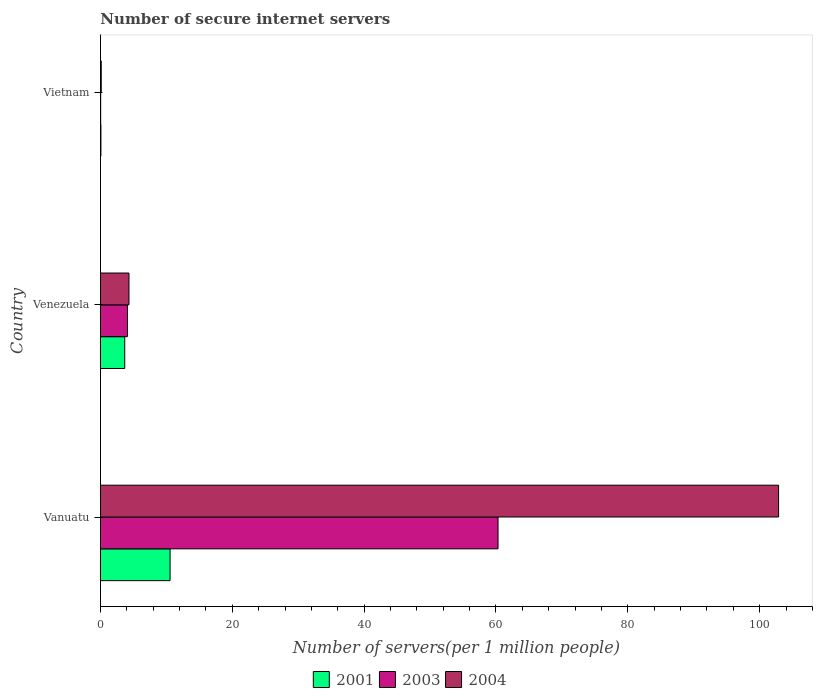How many different coloured bars are there?
Your response must be concise. 3. Are the number of bars per tick equal to the number of legend labels?
Your response must be concise. Yes. What is the label of the 3rd group of bars from the top?
Your answer should be compact. Vanuatu. What is the number of secure internet servers in 2001 in Venezuela?
Keep it short and to the point. 3.69. Across all countries, what is the maximum number of secure internet servers in 2001?
Your answer should be compact. 10.57. Across all countries, what is the minimum number of secure internet servers in 2001?
Ensure brevity in your answer.  0.08. In which country was the number of secure internet servers in 2004 maximum?
Your answer should be very brief. Vanuatu. In which country was the number of secure internet servers in 2001 minimum?
Provide a short and direct response. Vietnam. What is the total number of secure internet servers in 2001 in the graph?
Make the answer very short. 14.33. What is the difference between the number of secure internet servers in 2003 in Venezuela and that in Vietnam?
Offer a very short reply. 4.06. What is the difference between the number of secure internet servers in 2003 in Vietnam and the number of secure internet servers in 2004 in Vanuatu?
Provide a short and direct response. -102.83. What is the average number of secure internet servers in 2001 per country?
Provide a succinct answer. 4.78. What is the difference between the number of secure internet servers in 2004 and number of secure internet servers in 2001 in Venezuela?
Your answer should be compact. 0.64. What is the ratio of the number of secure internet servers in 2003 in Vanuatu to that in Venezuela?
Keep it short and to the point. 14.71. What is the difference between the highest and the second highest number of secure internet servers in 2003?
Give a very brief answer. 56.21. What is the difference between the highest and the lowest number of secure internet servers in 2004?
Your answer should be very brief. 102.75. In how many countries, is the number of secure internet servers in 2004 greater than the average number of secure internet servers in 2004 taken over all countries?
Offer a very short reply. 1. How many bars are there?
Your answer should be very brief. 9. How many countries are there in the graph?
Keep it short and to the point. 3. What is the difference between two consecutive major ticks on the X-axis?
Provide a succinct answer. 20. Where does the legend appear in the graph?
Keep it short and to the point. Bottom center. What is the title of the graph?
Keep it short and to the point. Number of secure internet servers. What is the label or title of the X-axis?
Provide a succinct answer. Number of servers(per 1 million people). What is the label or title of the Y-axis?
Offer a terse response. Country. What is the Number of servers(per 1 million people) of 2001 in Vanuatu?
Provide a succinct answer. 10.57. What is the Number of servers(per 1 million people) of 2003 in Vanuatu?
Give a very brief answer. 60.31. What is the Number of servers(per 1 million people) in 2004 in Vanuatu?
Make the answer very short. 102.87. What is the Number of servers(per 1 million people) of 2001 in Venezuela?
Ensure brevity in your answer.  3.69. What is the Number of servers(per 1 million people) of 2003 in Venezuela?
Keep it short and to the point. 4.1. What is the Number of servers(per 1 million people) in 2004 in Venezuela?
Your answer should be compact. 4.33. What is the Number of servers(per 1 million people) of 2001 in Vietnam?
Keep it short and to the point. 0.08. What is the Number of servers(per 1 million people) in 2003 in Vietnam?
Ensure brevity in your answer.  0.04. What is the Number of servers(per 1 million people) in 2004 in Vietnam?
Make the answer very short. 0.12. Across all countries, what is the maximum Number of servers(per 1 million people) in 2001?
Your response must be concise. 10.57. Across all countries, what is the maximum Number of servers(per 1 million people) of 2003?
Your answer should be very brief. 60.31. Across all countries, what is the maximum Number of servers(per 1 million people) in 2004?
Your response must be concise. 102.87. Across all countries, what is the minimum Number of servers(per 1 million people) of 2001?
Your answer should be compact. 0.08. Across all countries, what is the minimum Number of servers(per 1 million people) of 2003?
Make the answer very short. 0.04. Across all countries, what is the minimum Number of servers(per 1 million people) in 2004?
Provide a short and direct response. 0.12. What is the total Number of servers(per 1 million people) of 2001 in the graph?
Make the answer very short. 14.33. What is the total Number of servers(per 1 million people) of 2003 in the graph?
Keep it short and to the point. 64.45. What is the total Number of servers(per 1 million people) of 2004 in the graph?
Offer a terse response. 107.32. What is the difference between the Number of servers(per 1 million people) in 2001 in Vanuatu and that in Venezuela?
Offer a terse response. 6.88. What is the difference between the Number of servers(per 1 million people) in 2003 in Vanuatu and that in Venezuela?
Keep it short and to the point. 56.21. What is the difference between the Number of servers(per 1 million people) of 2004 in Vanuatu and that in Venezuela?
Keep it short and to the point. 98.54. What is the difference between the Number of servers(per 1 million people) of 2001 in Vanuatu and that in Vietnam?
Provide a succinct answer. 10.49. What is the difference between the Number of servers(per 1 million people) of 2003 in Vanuatu and that in Vietnam?
Keep it short and to the point. 60.28. What is the difference between the Number of servers(per 1 million people) of 2004 in Vanuatu and that in Vietnam?
Give a very brief answer. 102.75. What is the difference between the Number of servers(per 1 million people) of 2001 in Venezuela and that in Vietnam?
Provide a short and direct response. 3.61. What is the difference between the Number of servers(per 1 million people) in 2003 in Venezuela and that in Vietnam?
Give a very brief answer. 4.06. What is the difference between the Number of servers(per 1 million people) of 2004 in Venezuela and that in Vietnam?
Ensure brevity in your answer.  4.21. What is the difference between the Number of servers(per 1 million people) of 2001 in Vanuatu and the Number of servers(per 1 million people) of 2003 in Venezuela?
Provide a short and direct response. 6.47. What is the difference between the Number of servers(per 1 million people) in 2001 in Vanuatu and the Number of servers(per 1 million people) in 2004 in Venezuela?
Ensure brevity in your answer.  6.23. What is the difference between the Number of servers(per 1 million people) of 2003 in Vanuatu and the Number of servers(per 1 million people) of 2004 in Venezuela?
Offer a terse response. 55.98. What is the difference between the Number of servers(per 1 million people) of 2001 in Vanuatu and the Number of servers(per 1 million people) of 2003 in Vietnam?
Offer a very short reply. 10.53. What is the difference between the Number of servers(per 1 million people) of 2001 in Vanuatu and the Number of servers(per 1 million people) of 2004 in Vietnam?
Make the answer very short. 10.44. What is the difference between the Number of servers(per 1 million people) of 2003 in Vanuatu and the Number of servers(per 1 million people) of 2004 in Vietnam?
Give a very brief answer. 60.19. What is the difference between the Number of servers(per 1 million people) in 2001 in Venezuela and the Number of servers(per 1 million people) in 2003 in Vietnam?
Offer a terse response. 3.65. What is the difference between the Number of servers(per 1 million people) in 2001 in Venezuela and the Number of servers(per 1 million people) in 2004 in Vietnam?
Your answer should be very brief. 3.57. What is the difference between the Number of servers(per 1 million people) of 2003 in Venezuela and the Number of servers(per 1 million people) of 2004 in Vietnam?
Ensure brevity in your answer.  3.98. What is the average Number of servers(per 1 million people) of 2001 per country?
Your response must be concise. 4.78. What is the average Number of servers(per 1 million people) in 2003 per country?
Your response must be concise. 21.48. What is the average Number of servers(per 1 million people) of 2004 per country?
Give a very brief answer. 35.77. What is the difference between the Number of servers(per 1 million people) in 2001 and Number of servers(per 1 million people) in 2003 in Vanuatu?
Your answer should be compact. -49.75. What is the difference between the Number of servers(per 1 million people) in 2001 and Number of servers(per 1 million people) in 2004 in Vanuatu?
Offer a terse response. -92.3. What is the difference between the Number of servers(per 1 million people) of 2003 and Number of servers(per 1 million people) of 2004 in Vanuatu?
Ensure brevity in your answer.  -42.56. What is the difference between the Number of servers(per 1 million people) of 2001 and Number of servers(per 1 million people) of 2003 in Venezuela?
Offer a terse response. -0.41. What is the difference between the Number of servers(per 1 million people) in 2001 and Number of servers(per 1 million people) in 2004 in Venezuela?
Offer a terse response. -0.64. What is the difference between the Number of servers(per 1 million people) in 2003 and Number of servers(per 1 million people) in 2004 in Venezuela?
Ensure brevity in your answer.  -0.23. What is the difference between the Number of servers(per 1 million people) in 2001 and Number of servers(per 1 million people) in 2003 in Vietnam?
Offer a terse response. 0.04. What is the difference between the Number of servers(per 1 million people) of 2001 and Number of servers(per 1 million people) of 2004 in Vietnam?
Make the answer very short. -0.05. What is the difference between the Number of servers(per 1 million people) in 2003 and Number of servers(per 1 million people) in 2004 in Vietnam?
Keep it short and to the point. -0.09. What is the ratio of the Number of servers(per 1 million people) of 2001 in Vanuatu to that in Venezuela?
Offer a very short reply. 2.86. What is the ratio of the Number of servers(per 1 million people) in 2003 in Vanuatu to that in Venezuela?
Ensure brevity in your answer.  14.71. What is the ratio of the Number of servers(per 1 million people) in 2004 in Vanuatu to that in Venezuela?
Keep it short and to the point. 23.75. What is the ratio of the Number of servers(per 1 million people) of 2001 in Vanuatu to that in Vietnam?
Keep it short and to the point. 138.45. What is the ratio of the Number of servers(per 1 million people) of 2003 in Vanuatu to that in Vietnam?
Ensure brevity in your answer.  1617.74. What is the ratio of the Number of servers(per 1 million people) of 2004 in Vanuatu to that in Vietnam?
Ensure brevity in your answer.  837.72. What is the ratio of the Number of servers(per 1 million people) in 2001 in Venezuela to that in Vietnam?
Your response must be concise. 48.34. What is the ratio of the Number of servers(per 1 million people) in 2003 in Venezuela to that in Vietnam?
Provide a short and direct response. 109.96. What is the ratio of the Number of servers(per 1 million people) in 2004 in Venezuela to that in Vietnam?
Offer a terse response. 35.28. What is the difference between the highest and the second highest Number of servers(per 1 million people) in 2001?
Your answer should be very brief. 6.88. What is the difference between the highest and the second highest Number of servers(per 1 million people) in 2003?
Provide a succinct answer. 56.21. What is the difference between the highest and the second highest Number of servers(per 1 million people) in 2004?
Ensure brevity in your answer.  98.54. What is the difference between the highest and the lowest Number of servers(per 1 million people) of 2001?
Give a very brief answer. 10.49. What is the difference between the highest and the lowest Number of servers(per 1 million people) in 2003?
Provide a succinct answer. 60.28. What is the difference between the highest and the lowest Number of servers(per 1 million people) of 2004?
Offer a terse response. 102.75. 